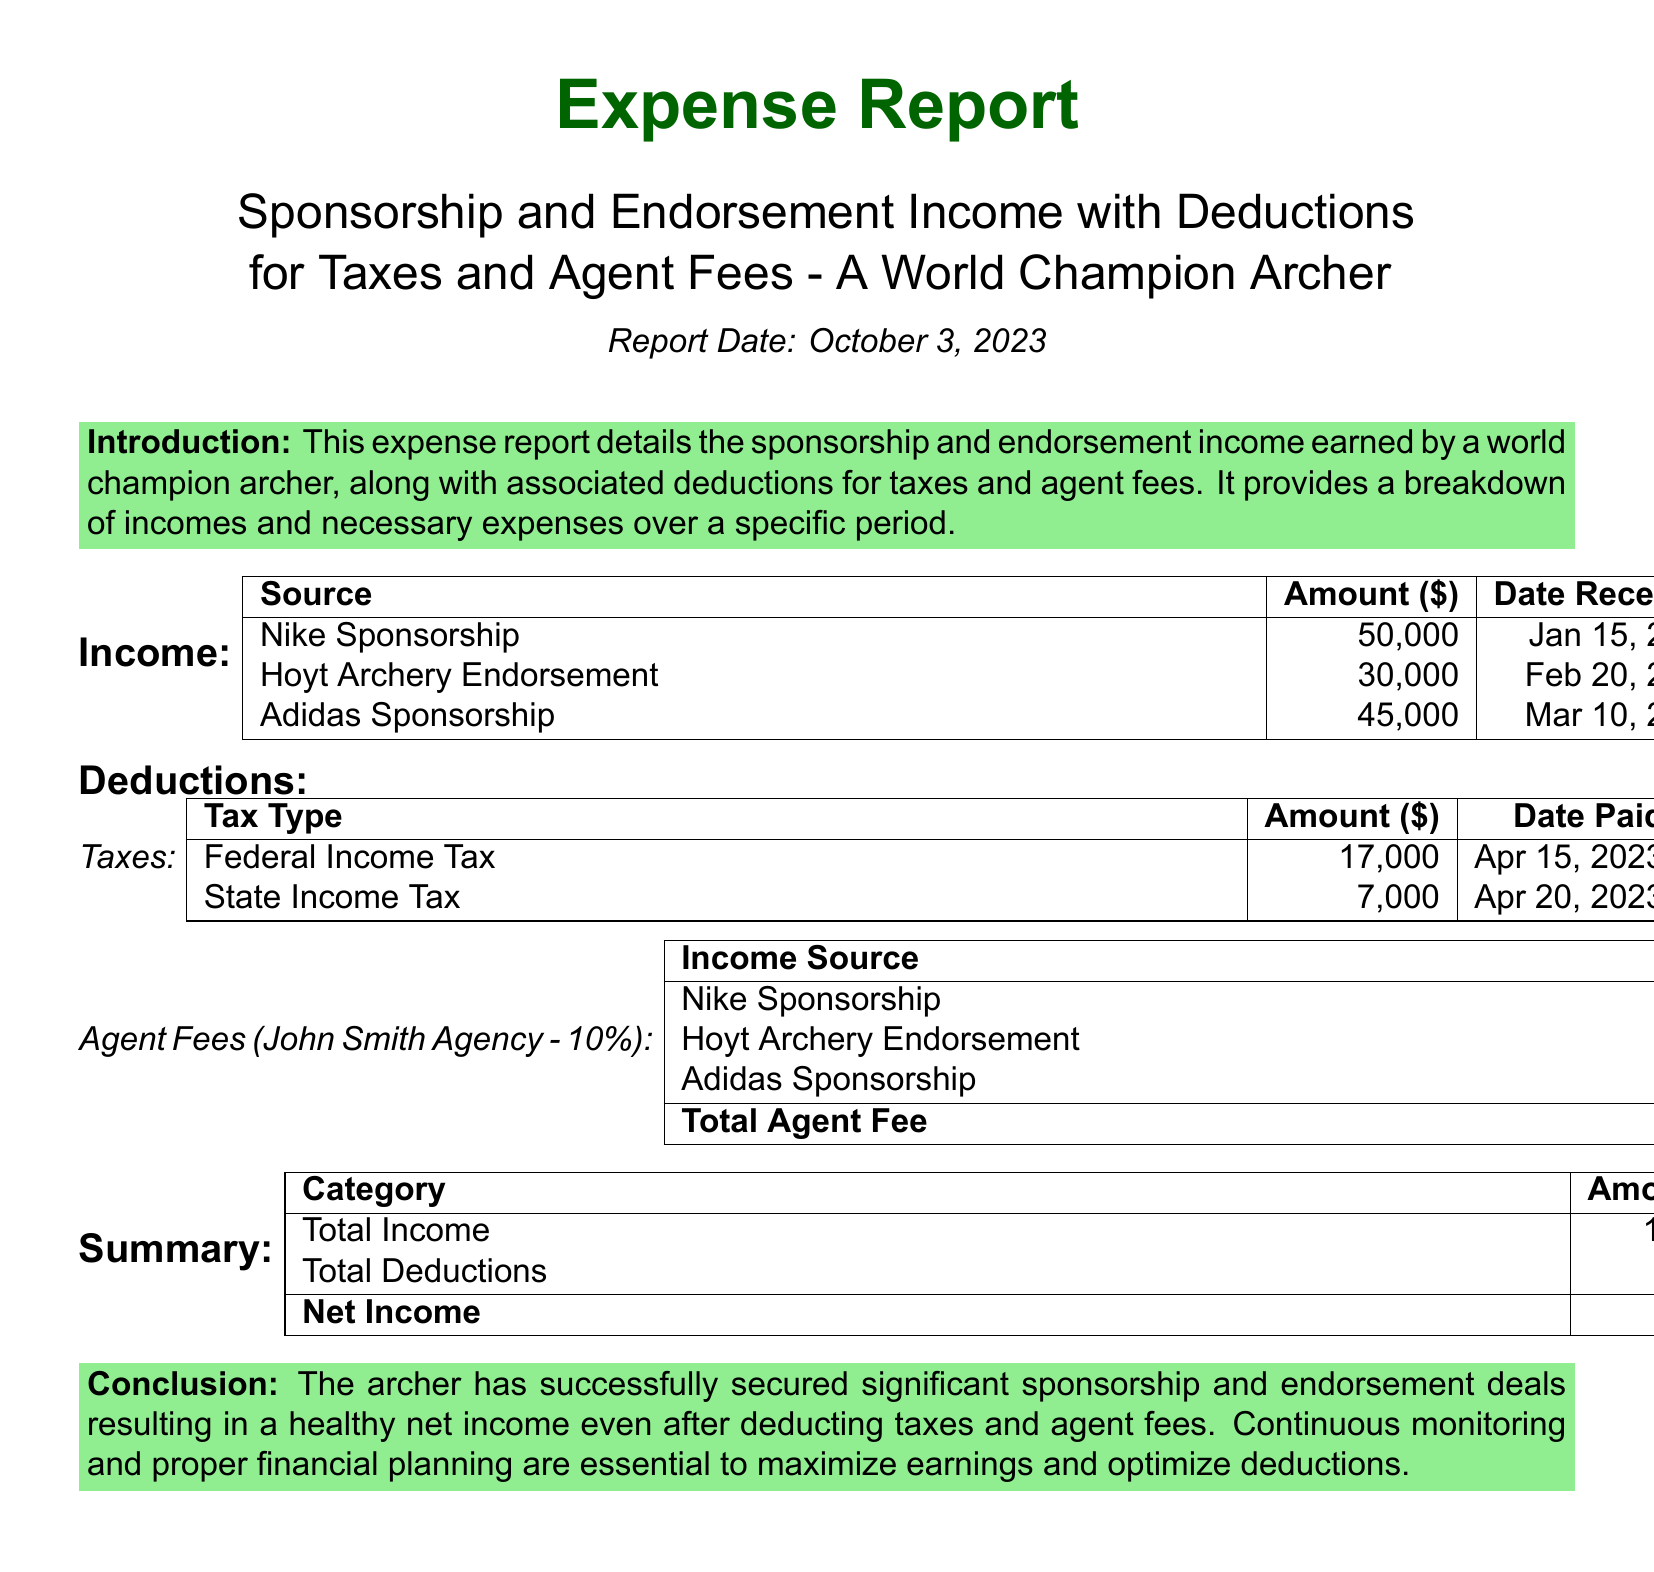What is the total income? The total income is the sum of all income sources outlined in the document, which includes Nike Sponsorship, Hoyt Archery Endorsement, and Adidas Sponsorship.
Answer: 125,000 What is the amount for Federal Income Tax? The document specifies the amount that has been paid for Federal Income Tax.
Answer: 17,000 Who is the agent for the sponsorships? The document mentions that the agent is the John Smith Agency.
Answer: John Smith Agency What is the date the Hoyt Archery Endorsement was received? The document provides the specific date that the Hoyt Archery Endorsement income was received.
Answer: Feb 20, 2023 What is the total agent fee? The total agent fee is calculated from the fees associated with each income source listed in the report.
Answer: 12,500 What is the state income tax amount paid? The document lists the amount that has been paid for State Income Tax.
Answer: 7,000 What was the amount received from Adidas Sponsorship? The document provides the exact amount received from the Adidas Sponsorship.
Answer: 45,000 What is the net income after deductions? The net income is determined by subtracting total deductions from total income as stated in the summary.
Answer: 88,500 How much was deducted for taxes in total? The total deductions for taxes is the sum of Federal and State Income Taxes mentioned in the deductions section.
Answer: 24,000 